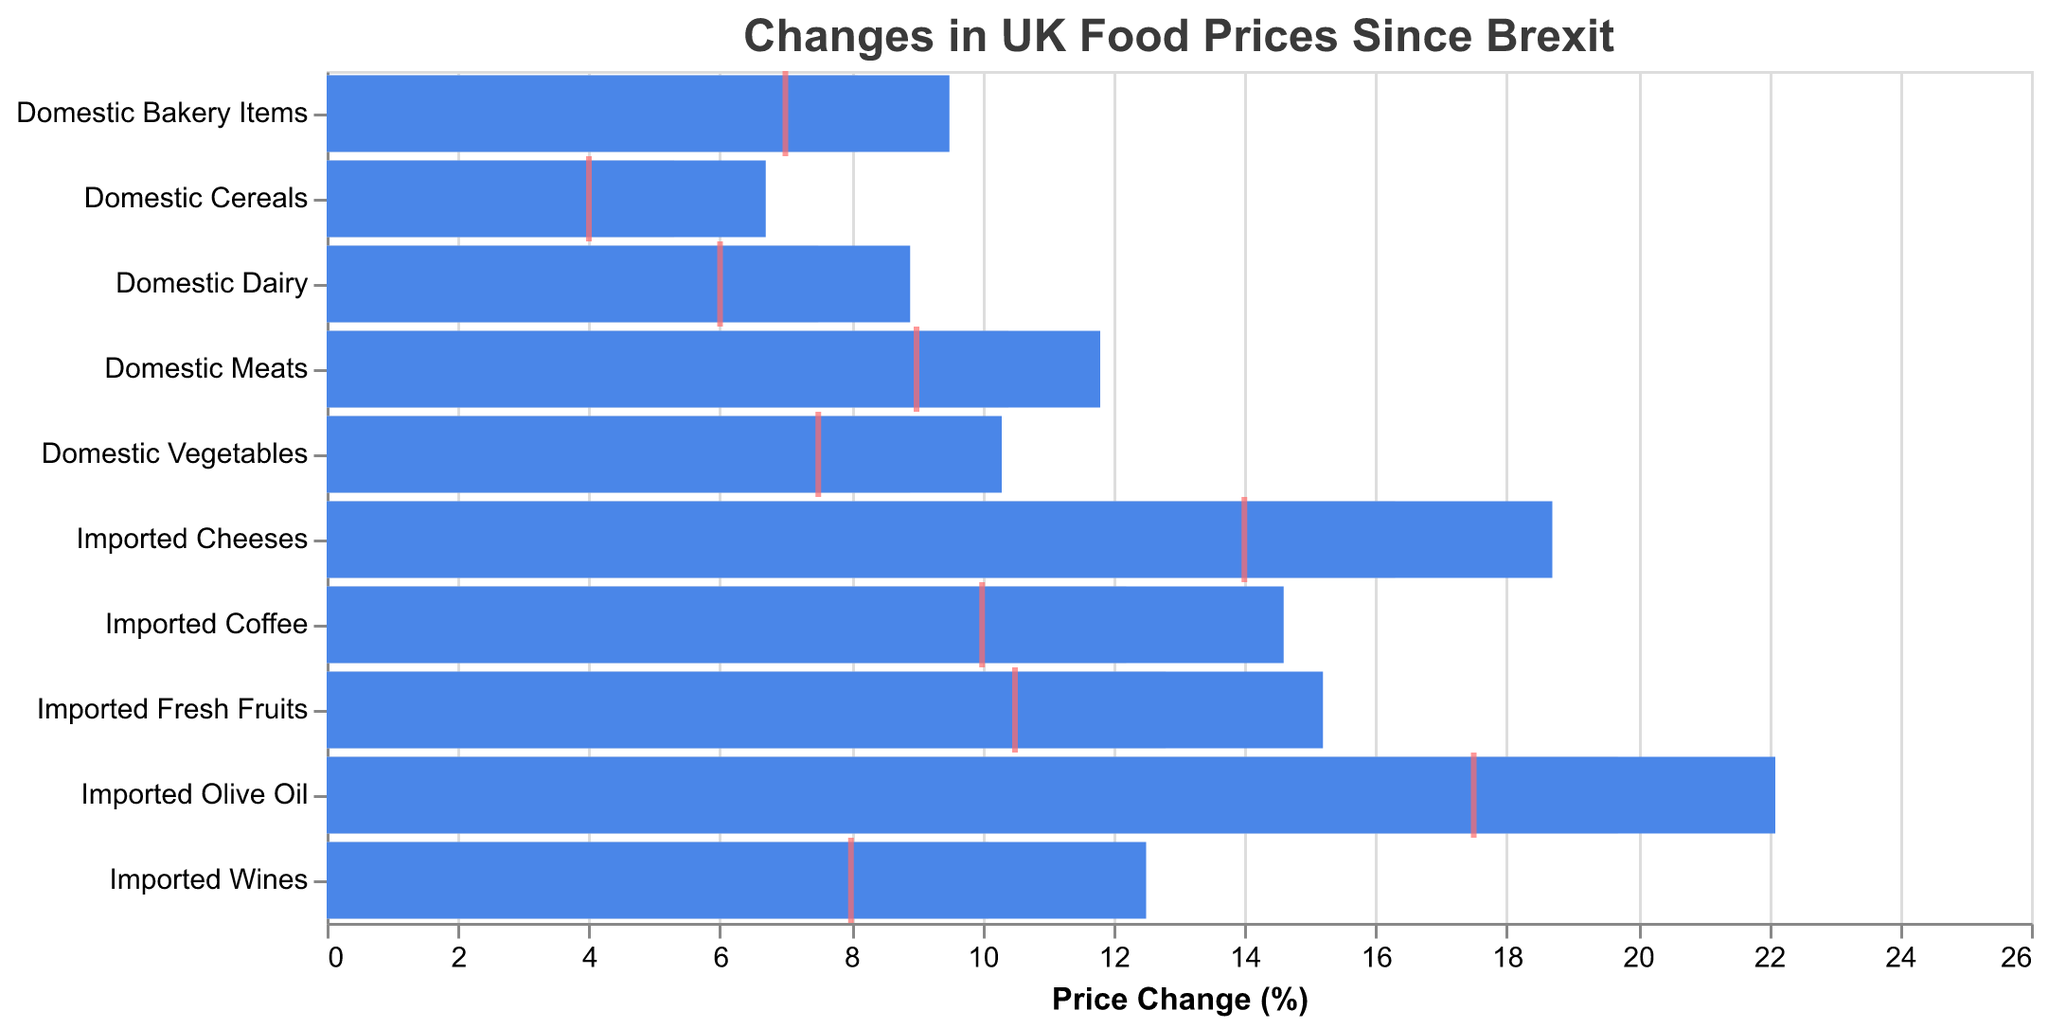What's the title of the chart? The title is positioned at the top of the chart and typically describes the overall theme or subject. Here, it reads "Changes in UK Food Prices Since Brexit".
Answer: Changes in UK Food Prices Since Brexit How many categories of food are displayed in the chart? Each bar in the chart represents a distinct category of food, and by counting them, we can determine the total number.
Answer: 10 Which category has the highest actual price change? The bar with the highest value indicates the largest actual price change. "Imported Olive Oil" has the highest bar value at 22.1%.
Answer: Imported Olive Oil What is the target price change for Domestic Bakery Items? The red tick mark represents the target price change. For Domestic Bakery Items, it is located at the 7.0% mark.
Answer: 7.0% Compare the actual and comparative price changes for Imported Wines. What is the difference? The actual price change for Imported Wines is 12.5%, and the comparative price change is 10.1%. The difference is calculated by subtracting the comparative value from the actual value: 12.5% - 10.1% = 2.4%.
Answer: 2.4% Which category has the smallest target price change? By comparing the positions of the red tick marks, "Domestic Cereals" has the smallest target price change at 4.0%.
Answer: Domestic Cereals How much more did Imported Fresh Fruits' actual price change exceed its target? The actual price change for Imported Fresh Fruits is 15.2%, and its target is 10.5%. The difference is: 15.2% - 10.5% = 4.7%.
Answer: 4.7% Did any domestic products meet or exceed their target price change? Reviewing the red tick marks (targets) and comparing them with the actual changes for domestic products, none of the categories met or exceeded their target price change.
Answer: No Which has a greater difference between actual and comparative price changes: Imported Cheeses or Domestic Meats? For Imported Cheeses, the difference is 18.7% - 16.3% = 2.4%. For Domestic Meats, the difference is 11.8% - 10.4% = 1.4%. Imported Cheeses have a greater difference.
Answer: Imported Cheeses Among the domestic products, which category has the highest actual price change? By examining the actual price changes of domestic products, "Domestic Meats" shows the highest actual price change at 11.8%.
Answer: Domestic Meats 